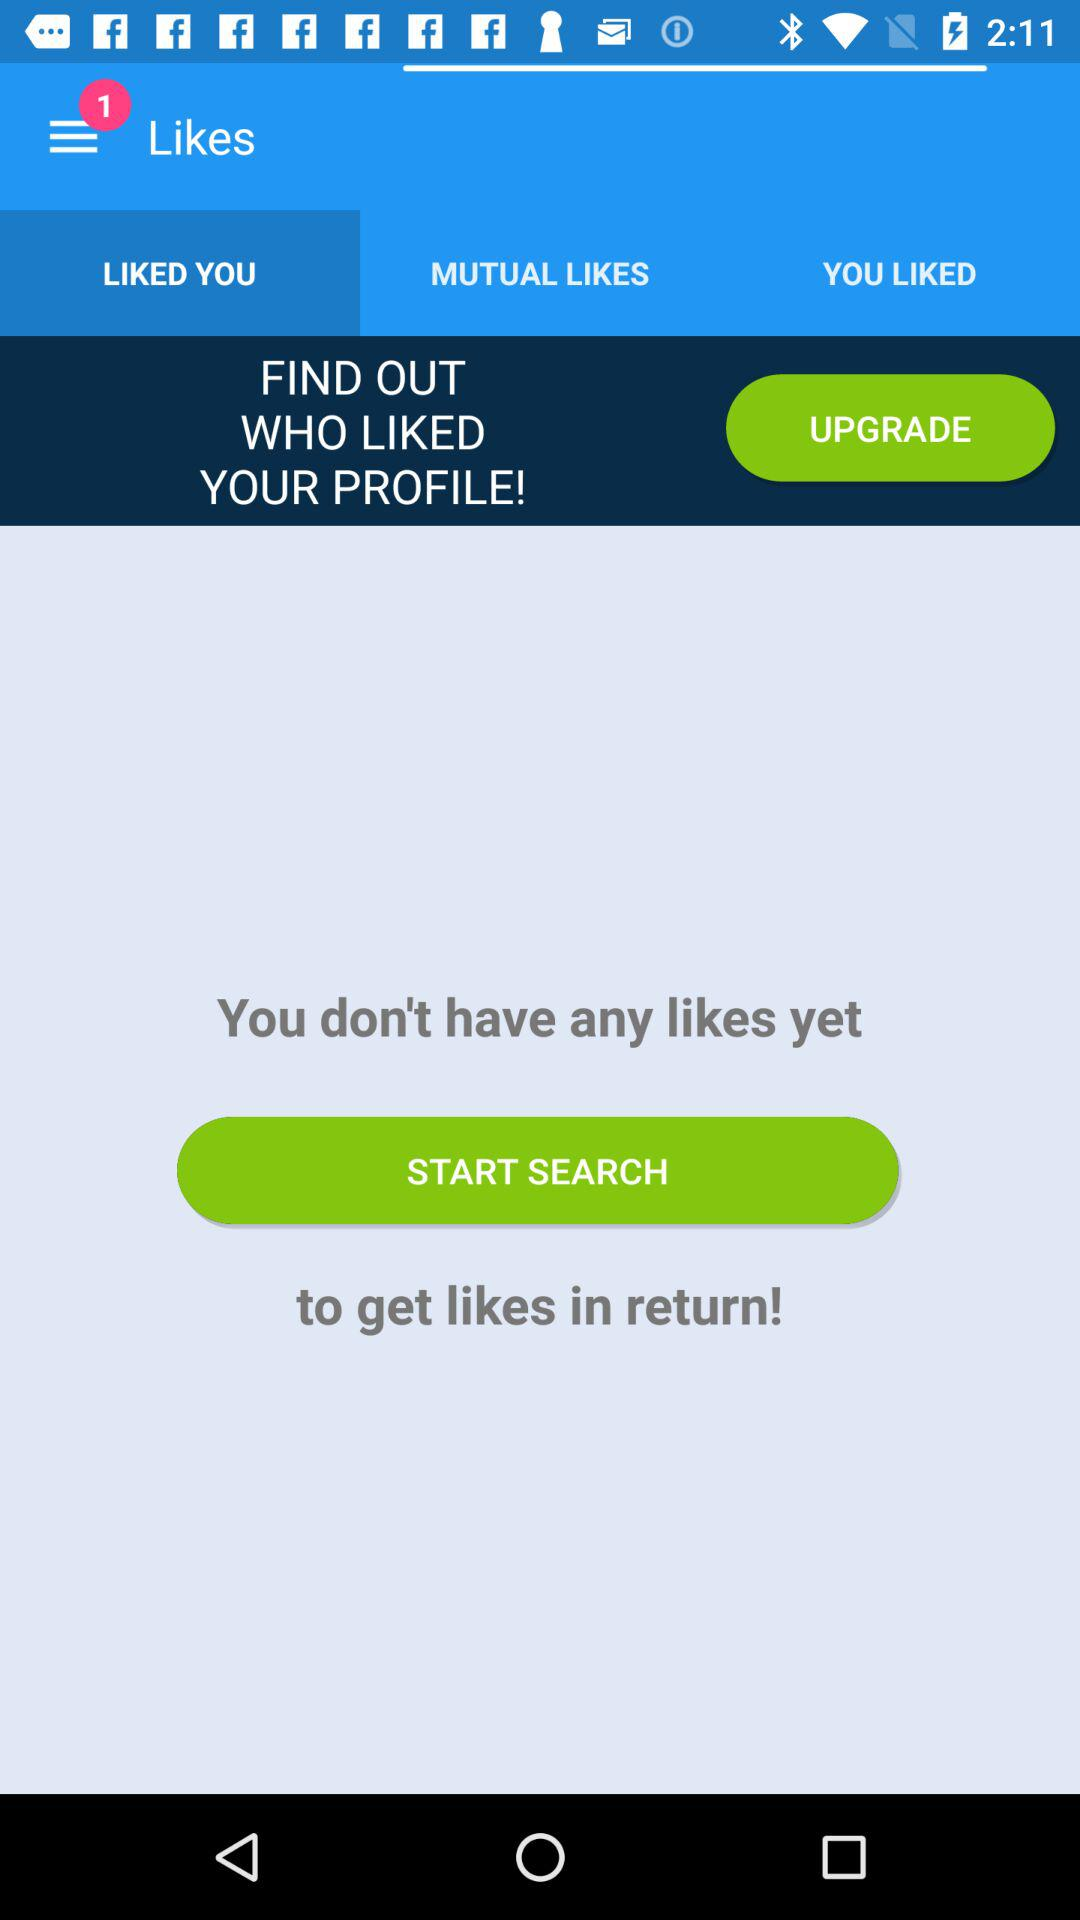How much does the upgrade cost?
When the provided information is insufficient, respond with <no answer>. <no answer> 